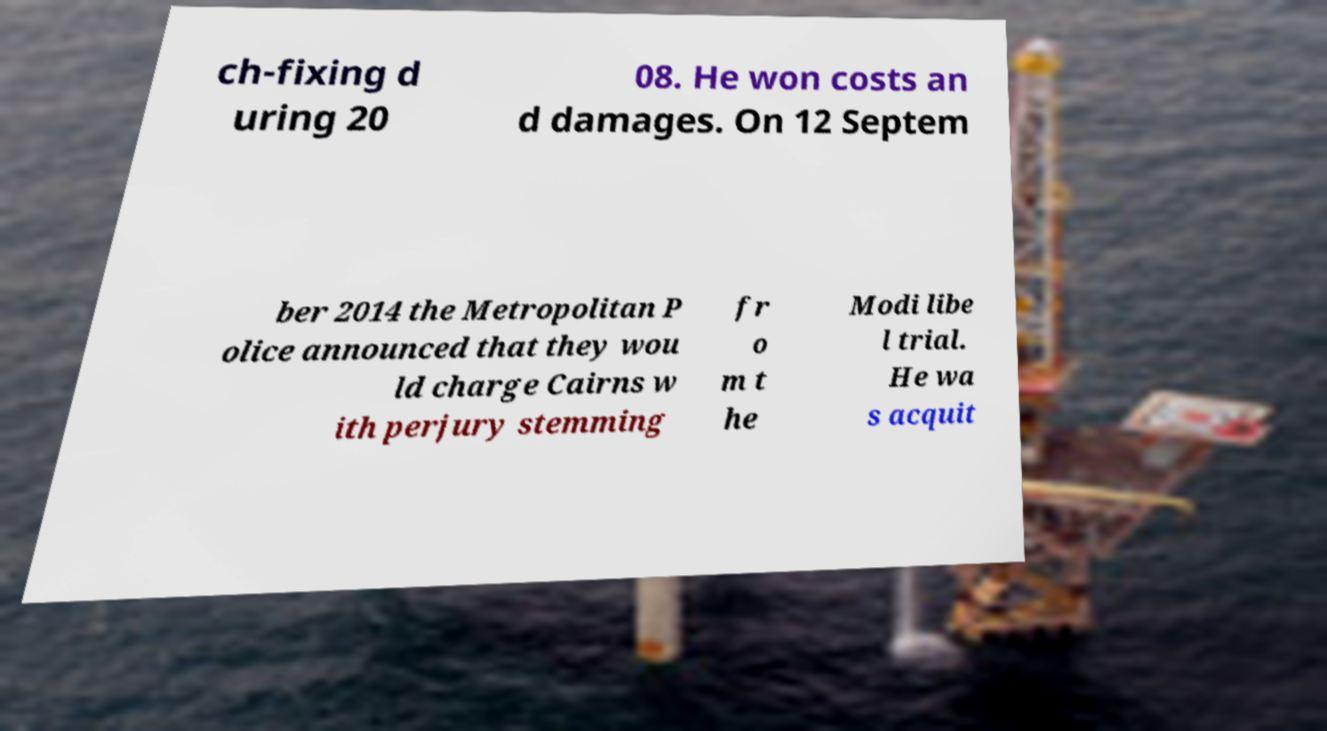Can you read and provide the text displayed in the image?This photo seems to have some interesting text. Can you extract and type it out for me? ch-fixing d uring 20 08. He won costs an d damages. On 12 Septem ber 2014 the Metropolitan P olice announced that they wou ld charge Cairns w ith perjury stemming fr o m t he Modi libe l trial. He wa s acquit 